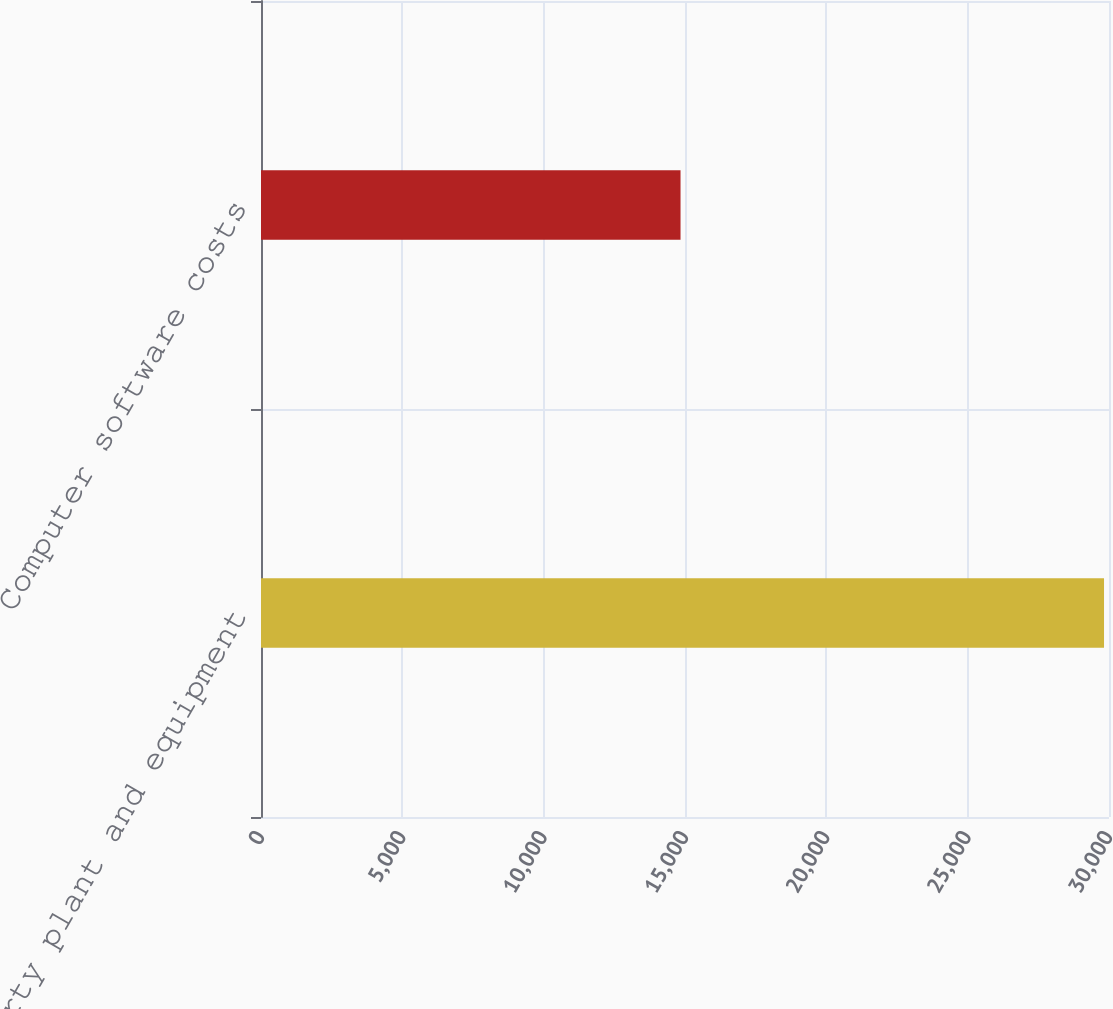<chart> <loc_0><loc_0><loc_500><loc_500><bar_chart><fcel>Property plant and equipment<fcel>Computer software costs<nl><fcel>29824<fcel>14842<nl></chart> 